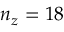<formula> <loc_0><loc_0><loc_500><loc_500>n _ { z } = 1 8</formula> 